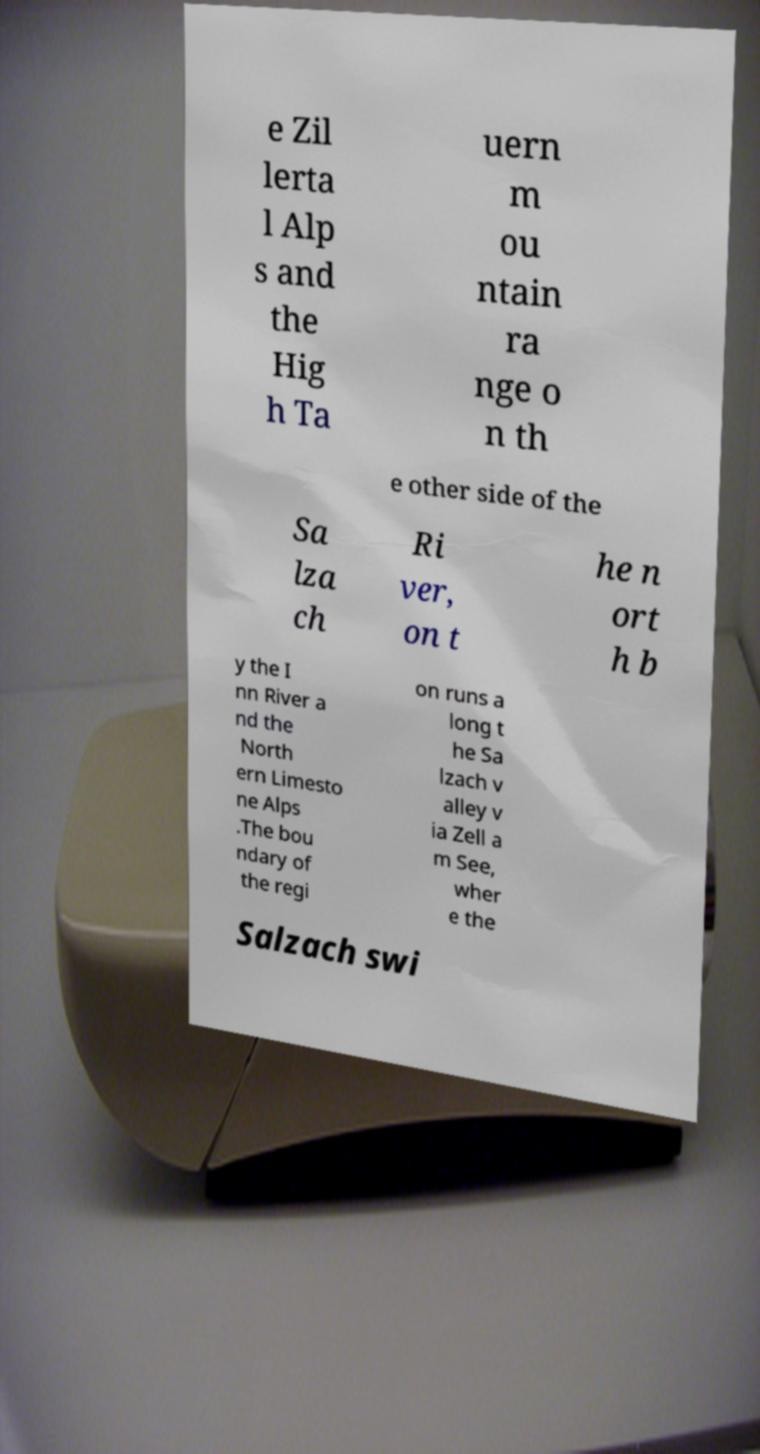Could you extract and type out the text from this image? e Zil lerta l Alp s and the Hig h Ta uern m ou ntain ra nge o n th e other side of the Sa lza ch Ri ver, on t he n ort h b y the I nn River a nd the North ern Limesto ne Alps .The bou ndary of the regi on runs a long t he Sa lzach v alley v ia Zell a m See, wher e the Salzach swi 